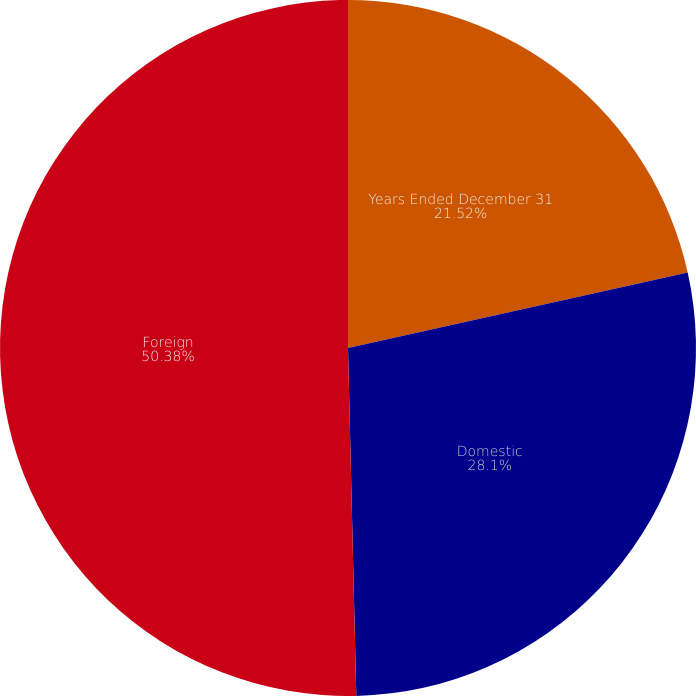Convert chart. <chart><loc_0><loc_0><loc_500><loc_500><pie_chart><fcel>Years Ended December 31<fcel>Domestic<fcel>Foreign<nl><fcel>21.52%<fcel>28.1%<fcel>50.38%<nl></chart> 